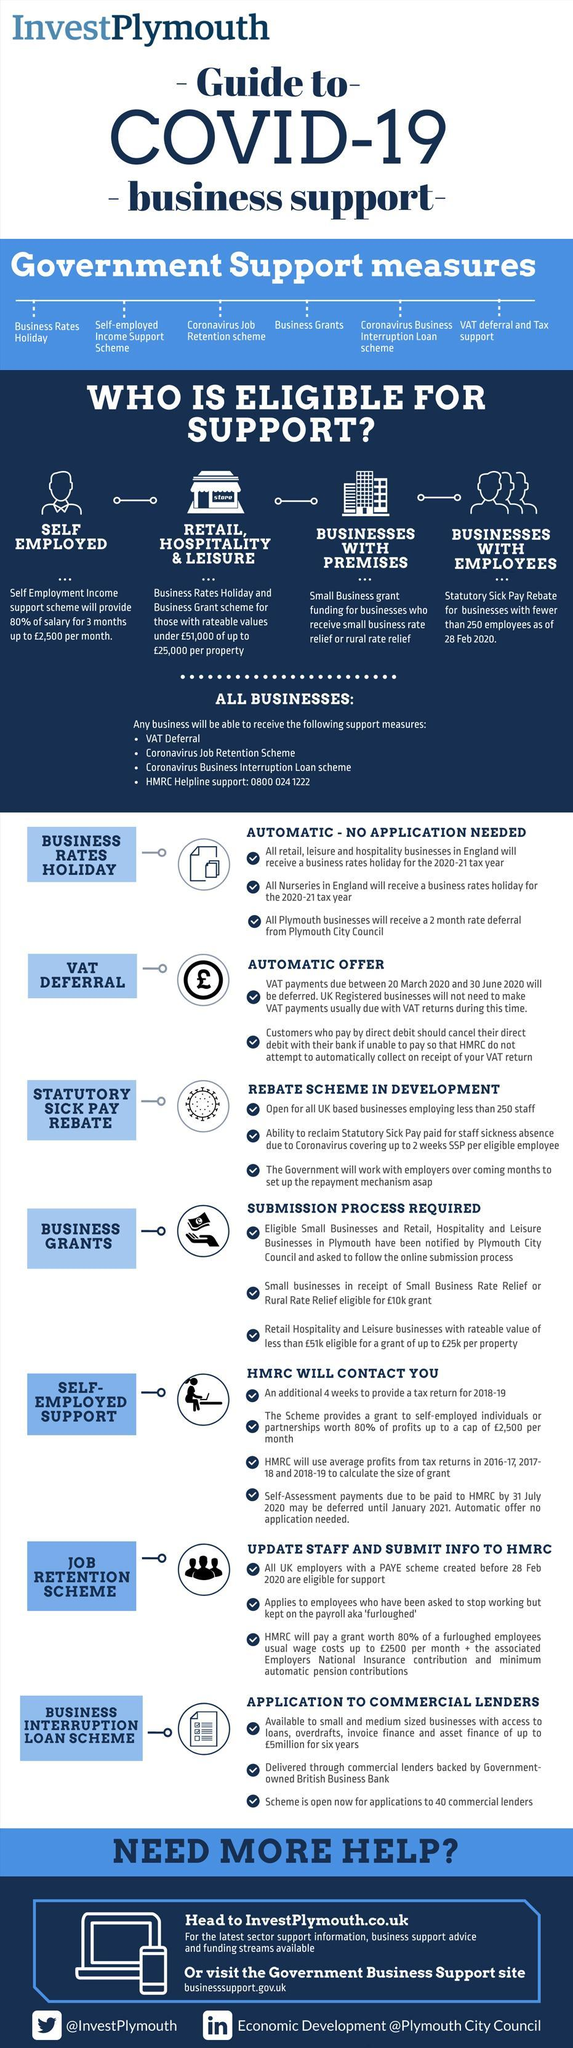what is the third application  procedure under the subtopic business interruption loan scheme?
Answer the question with a short phrase. scheme is open now for applications to 40 commercial lenders how many application procedure tips are given under the subtopic self-employed support? 4 what is the fourth item given under support measures? business grants What are the support schemes applicable for all the businesses? VAT deferral, coronavirus job retention scheme, coronavirus business interruption loan scheme what is the fifth item given under support measures? coronavirus business interruption loan scheme What are the support schemes that requires no application? business rates holiday, VAT deferral How many different kinds of support measures are given in this infographic? 6 Application procedure of How many different support schemes are given in detail? 7 what is the third application procedure under the subtopic self-employed support? HMRC will use average profits from tax returns in 2016-17, 2017-18, 2018-19 to calculate the size of grant details of which support scheme is given near the pound symbol? VAT deferral 